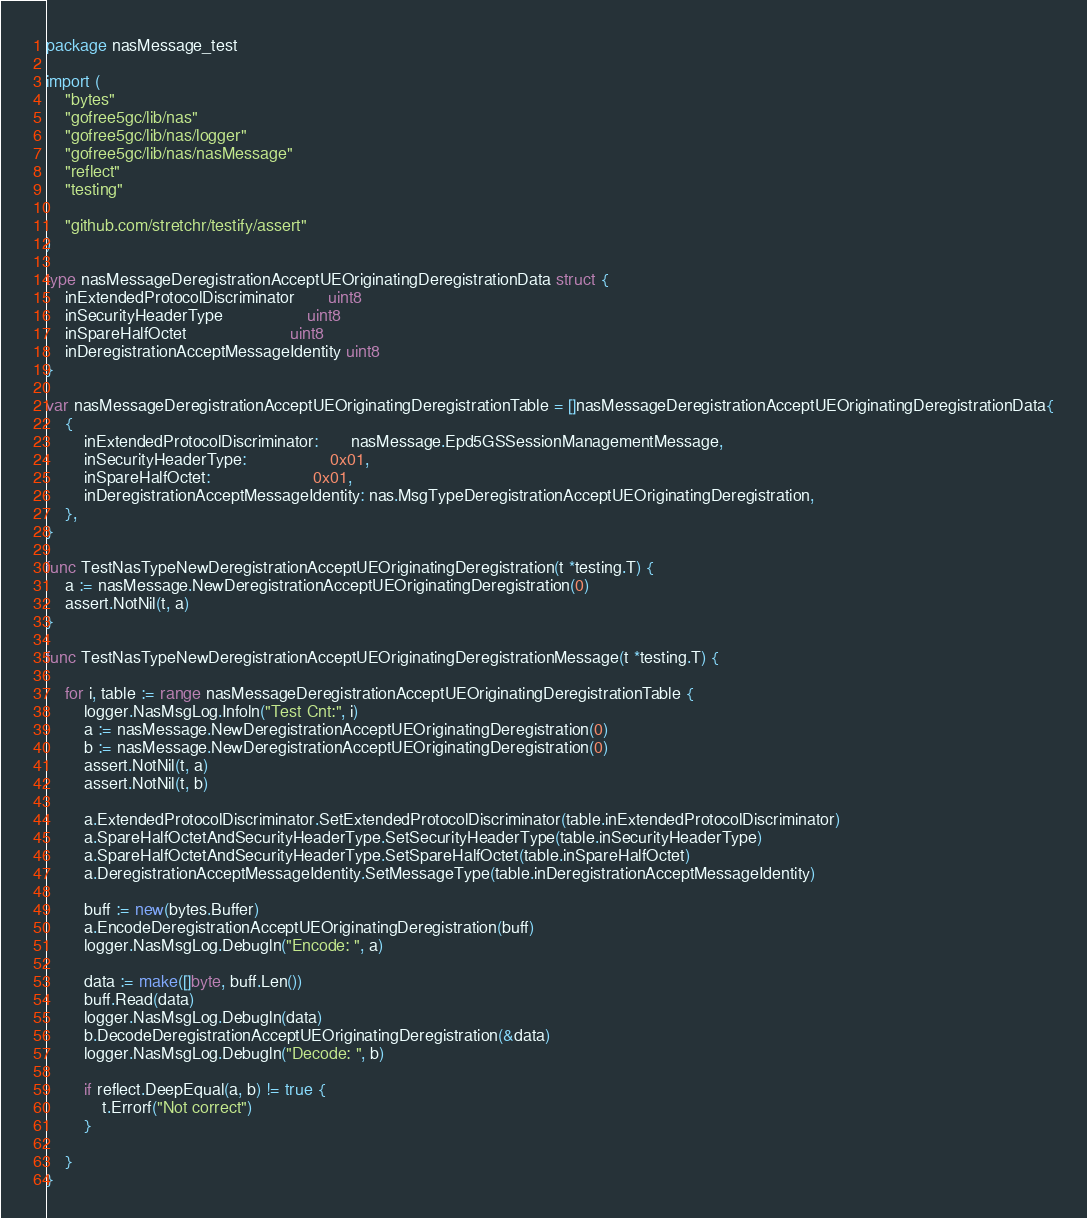Convert code to text. <code><loc_0><loc_0><loc_500><loc_500><_Go_>package nasMessage_test

import (
	"bytes"
	"gofree5gc/lib/nas"
	"gofree5gc/lib/nas/logger"
	"gofree5gc/lib/nas/nasMessage"
	"reflect"
	"testing"

	"github.com/stretchr/testify/assert"
)

type nasMessageDeregistrationAcceptUEOriginatingDeregistrationData struct {
	inExtendedProtocolDiscriminator       uint8
	inSecurityHeaderType                  uint8
	inSpareHalfOctet                      uint8
	inDeregistrationAcceptMessageIdentity uint8
}

var nasMessageDeregistrationAcceptUEOriginatingDeregistrationTable = []nasMessageDeregistrationAcceptUEOriginatingDeregistrationData{
	{
		inExtendedProtocolDiscriminator:       nasMessage.Epd5GSSessionManagementMessage,
		inSecurityHeaderType:                  0x01,
		inSpareHalfOctet:                      0x01,
		inDeregistrationAcceptMessageIdentity: nas.MsgTypeDeregistrationAcceptUEOriginatingDeregistration,
	},
}

func TestNasTypeNewDeregistrationAcceptUEOriginatingDeregistration(t *testing.T) {
	a := nasMessage.NewDeregistrationAcceptUEOriginatingDeregistration(0)
	assert.NotNil(t, a)
}

func TestNasTypeNewDeregistrationAcceptUEOriginatingDeregistrationMessage(t *testing.T) {

	for i, table := range nasMessageDeregistrationAcceptUEOriginatingDeregistrationTable {
		logger.NasMsgLog.Infoln("Test Cnt:", i)
		a := nasMessage.NewDeregistrationAcceptUEOriginatingDeregistration(0)
		b := nasMessage.NewDeregistrationAcceptUEOriginatingDeregistration(0)
		assert.NotNil(t, a)
		assert.NotNil(t, b)

		a.ExtendedProtocolDiscriminator.SetExtendedProtocolDiscriminator(table.inExtendedProtocolDiscriminator)
		a.SpareHalfOctetAndSecurityHeaderType.SetSecurityHeaderType(table.inSecurityHeaderType)
		a.SpareHalfOctetAndSecurityHeaderType.SetSpareHalfOctet(table.inSpareHalfOctet)
		a.DeregistrationAcceptMessageIdentity.SetMessageType(table.inDeregistrationAcceptMessageIdentity)

		buff := new(bytes.Buffer)
		a.EncodeDeregistrationAcceptUEOriginatingDeregistration(buff)
		logger.NasMsgLog.Debugln("Encode: ", a)

		data := make([]byte, buff.Len())
		buff.Read(data)
		logger.NasMsgLog.Debugln(data)
		b.DecodeDeregistrationAcceptUEOriginatingDeregistration(&data)
		logger.NasMsgLog.Debugln("Decode: ", b)

		if reflect.DeepEqual(a, b) != true {
			t.Errorf("Not correct")
		}

	}
}
</code> 